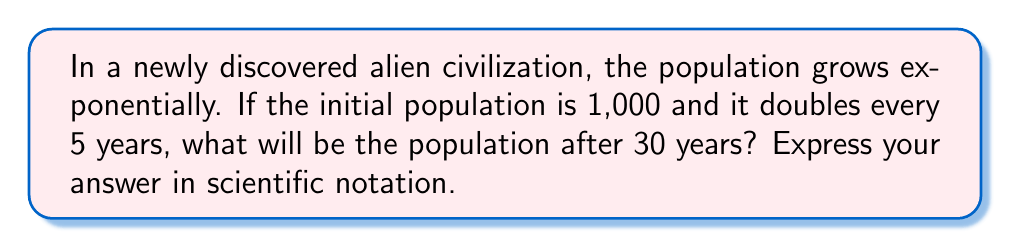Could you help me with this problem? Let's approach this step-by-step:

1) First, we need to determine how many times the population doubles in 30 years:
   $\frac{30 \text{ years}}{5 \text{ years per doubling}} = 6 \text{ doublings}$

2) We can express this as an exponential equation:
   $\text{Final Population} = \text{Initial Population} \times 2^{\text{number of doublings}}$

3) Plugging in our values:
   $\text{Final Population} = 1,000 \times 2^6$

4) Let's calculate $2^6$:
   $2^6 = 2 \times 2 \times 2 \times 2 \times 2 \times 2 = 64$

5) Now we can multiply:
   $\text{Final Population} = 1,000 \times 64 = 64,000$

6) To express this in scientific notation, we move the decimal point 4 places to the left:
   $64,000 = 6.4 \times 10^4$

Therefore, after 30 years, the alien population will be $6.4 \times 10^4$.
Answer: $6.4 \times 10^4$ 